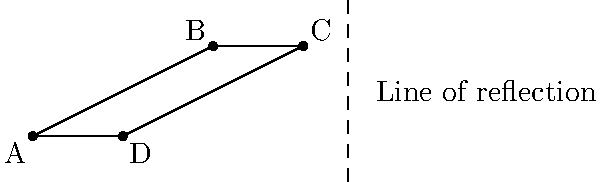A trapezoidal metal sheet ABCD is to be reflected across the line EF as shown in the diagram. If point A is reflected to (-2,-1), what are the coordinates of the reflected point C'? To find the coordinates of C' (the reflection of point C), we can follow these steps:

1) First, we need to find the equation of the line of reflection EF.
   From the diagram, we can see that EF is a vertical line with x = 3.

2) The reflection of a point across a vertical line follows this rule:
   If (x, y) is reflected across the line x = a, the reflected point is (2a - x, y).

3) We know that point C has coordinates (2, 3).

4) Applying the reflection rule:
   x' = 2(3) - 2 = 4
   y' = 3 (y-coordinate remains unchanged)

5) Therefore, the coordinates of C' are (4, 3).

We can verify this by checking that:
- The distance from C to the line of reflection is equal to the distance from C' to the line of reflection.
- The line connecting C and C' is perpendicular to the line of reflection.
Answer: (4, 3) 